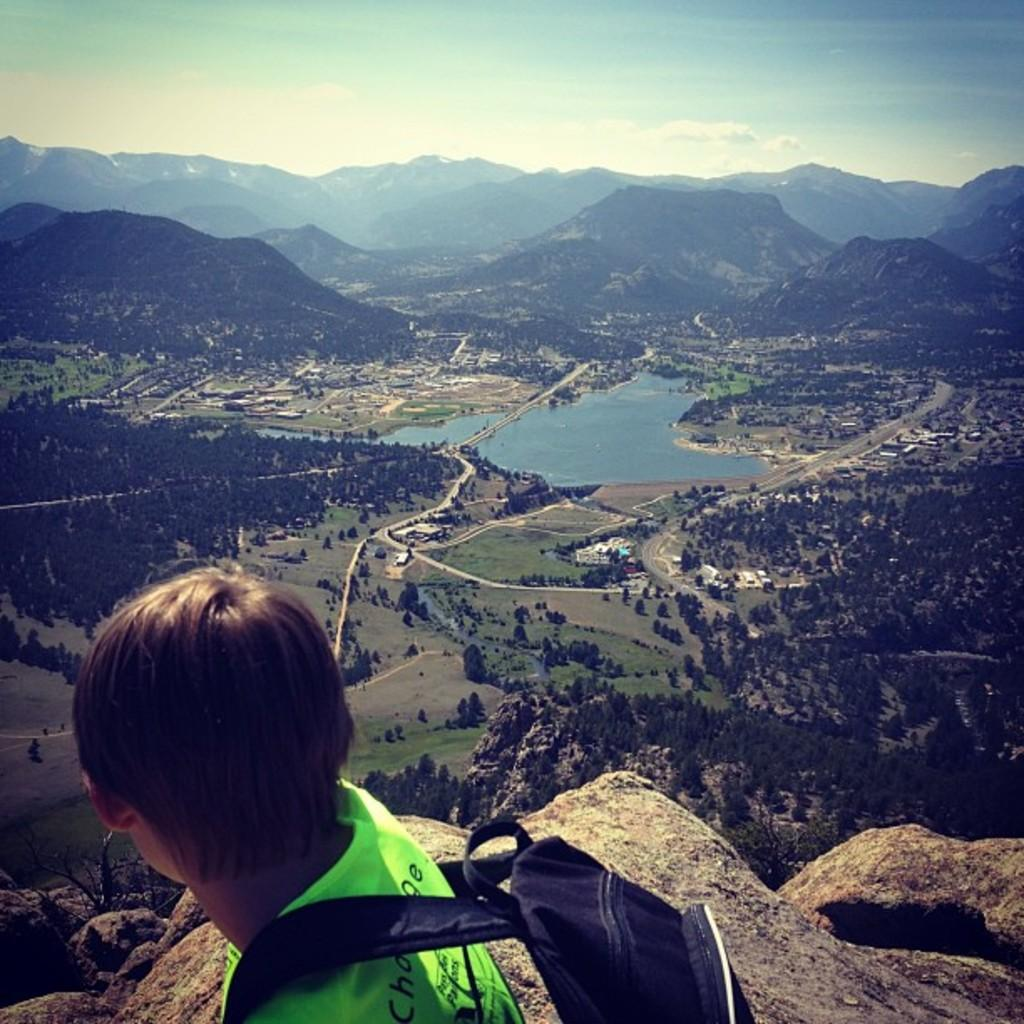What is present in the image? There is a person in the image, along with rocks, trees, water, hills, and the sky. What is the person wearing? The person is wearing a bag. What can be seen in the background of the image? In the background, there are trees, water, hills, and the sky. What is the condition of the sky in the image? The sky is visible in the background of the image, and clouds are present. How many pizzas can be seen in the image? There are no pizzas present in the image. What is the person's aunt doing in the image? There is no mention of an aunt in the image, and therefore no such activity can be observed. 